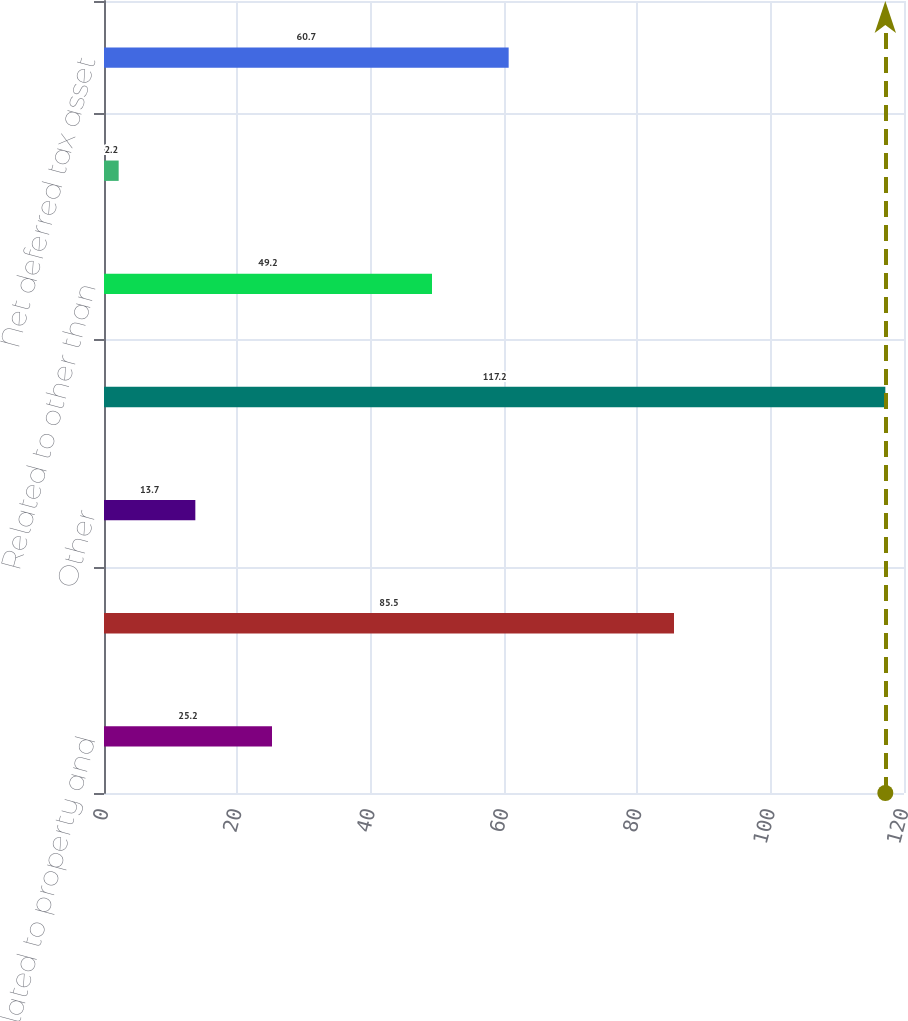Convert chart. <chart><loc_0><loc_0><loc_500><loc_500><bar_chart><fcel>Related to property and<fcel>Recognized in other<fcel>Other<fcel>Related to stock-based<fcel>Related to other than<fcel>Related to accrued<fcel>Net deferred tax asset<nl><fcel>25.2<fcel>85.5<fcel>13.7<fcel>117.2<fcel>49.2<fcel>2.2<fcel>60.7<nl></chart> 